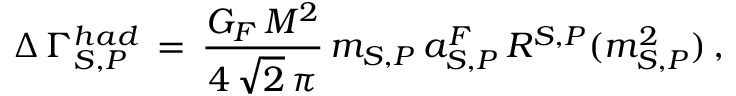Convert formula to latex. <formula><loc_0><loc_0><loc_500><loc_500>\Delta \, \Gamma _ { S , P } ^ { h a d } \, = \, \frac { G _ { F } \, M ^ { 2 } } { 4 \, \sqrt { 2 } \, \pi } \, m _ { S , P } \, a _ { S , P } ^ { F } \, R ^ { S , P } ( m _ { S , P } ^ { 2 } ) \, ,</formula> 